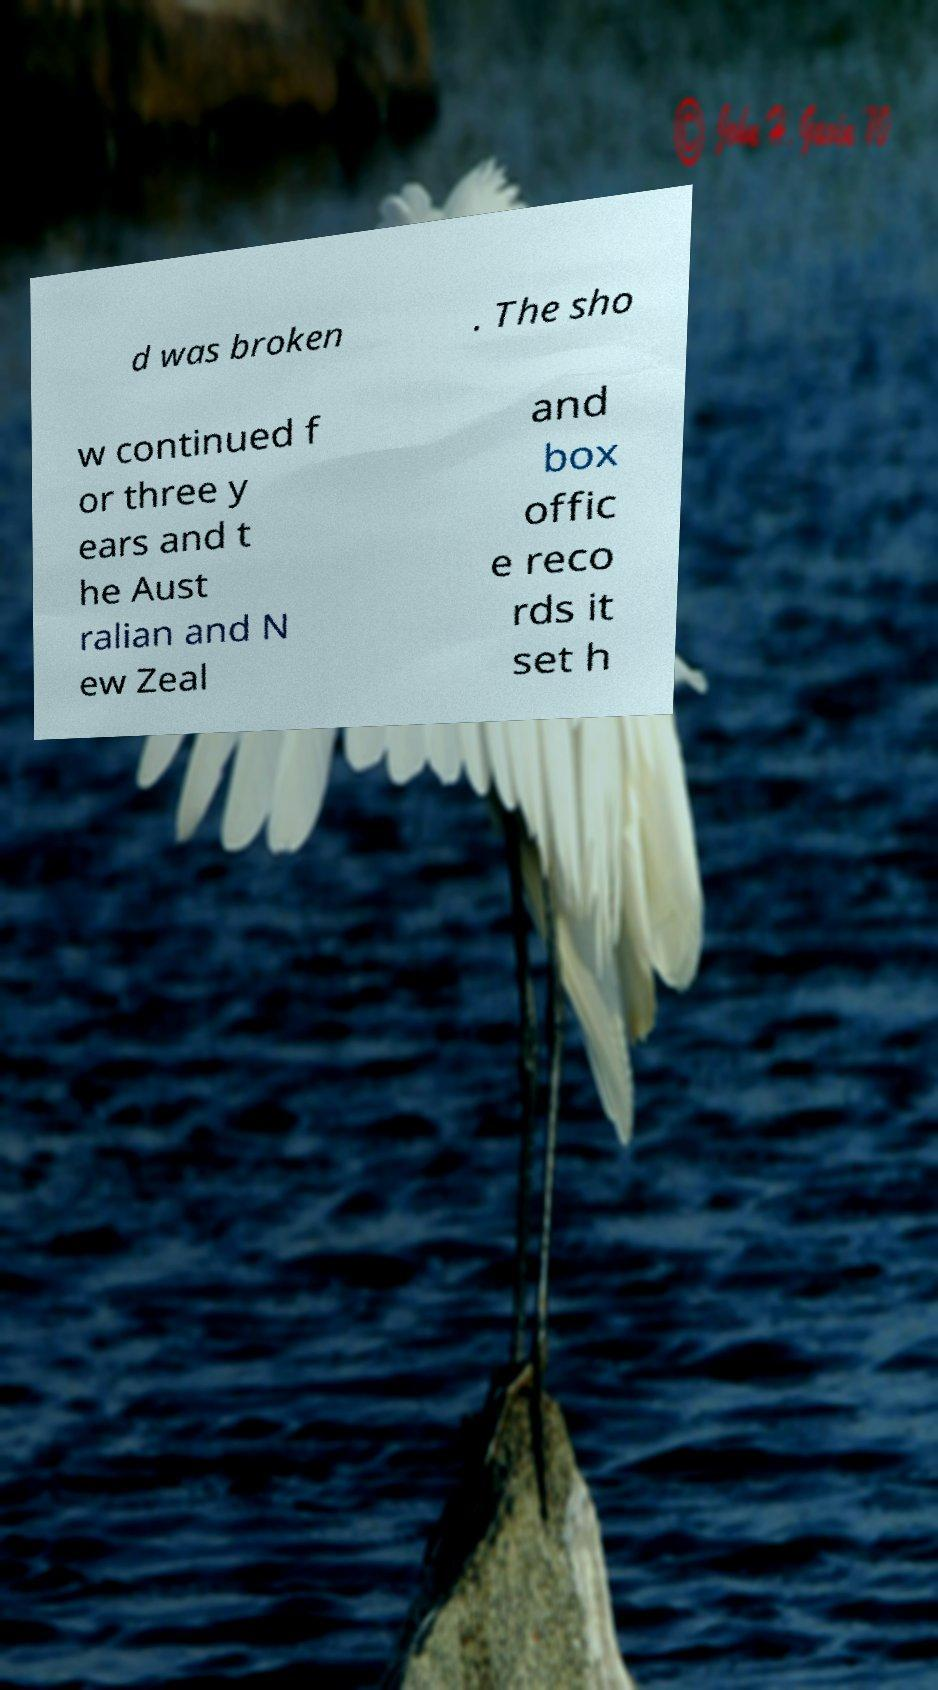Can you accurately transcribe the text from the provided image for me? d was broken . The sho w continued f or three y ears and t he Aust ralian and N ew Zeal and box offic e reco rds it set h 